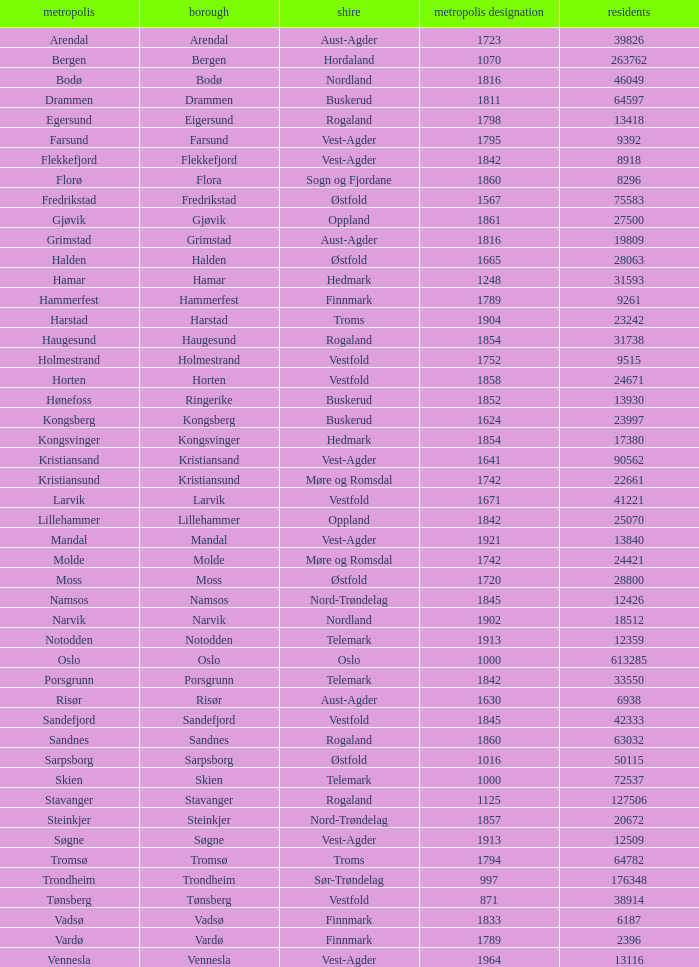Parse the full table. {'header': ['metropolis', 'borough', 'shire', 'metropolis designation', 'residents'], 'rows': [['Arendal', 'Arendal', 'Aust-Agder', '1723', '39826'], ['Bergen', 'Bergen', 'Hordaland', '1070', '263762'], ['Bodø', 'Bodø', 'Nordland', '1816', '46049'], ['Drammen', 'Drammen', 'Buskerud', '1811', '64597'], ['Egersund', 'Eigersund', 'Rogaland', '1798', '13418'], ['Farsund', 'Farsund', 'Vest-Agder', '1795', '9392'], ['Flekkefjord', 'Flekkefjord', 'Vest-Agder', '1842', '8918'], ['Florø', 'Flora', 'Sogn og Fjordane', '1860', '8296'], ['Fredrikstad', 'Fredrikstad', 'Østfold', '1567', '75583'], ['Gjøvik', 'Gjøvik', 'Oppland', '1861', '27500'], ['Grimstad', 'Grimstad', 'Aust-Agder', '1816', '19809'], ['Halden', 'Halden', 'Østfold', '1665', '28063'], ['Hamar', 'Hamar', 'Hedmark', '1248', '31593'], ['Hammerfest', 'Hammerfest', 'Finnmark', '1789', '9261'], ['Harstad', 'Harstad', 'Troms', '1904', '23242'], ['Haugesund', 'Haugesund', 'Rogaland', '1854', '31738'], ['Holmestrand', 'Holmestrand', 'Vestfold', '1752', '9515'], ['Horten', 'Horten', 'Vestfold', '1858', '24671'], ['Hønefoss', 'Ringerike', 'Buskerud', '1852', '13930'], ['Kongsberg', 'Kongsberg', 'Buskerud', '1624', '23997'], ['Kongsvinger', 'Kongsvinger', 'Hedmark', '1854', '17380'], ['Kristiansand', 'Kristiansand', 'Vest-Agder', '1641', '90562'], ['Kristiansund', 'Kristiansund', 'Møre og Romsdal', '1742', '22661'], ['Larvik', 'Larvik', 'Vestfold', '1671', '41221'], ['Lillehammer', 'Lillehammer', 'Oppland', '1842', '25070'], ['Mandal', 'Mandal', 'Vest-Agder', '1921', '13840'], ['Molde', 'Molde', 'Møre og Romsdal', '1742', '24421'], ['Moss', 'Moss', 'Østfold', '1720', '28800'], ['Namsos', 'Namsos', 'Nord-Trøndelag', '1845', '12426'], ['Narvik', 'Narvik', 'Nordland', '1902', '18512'], ['Notodden', 'Notodden', 'Telemark', '1913', '12359'], ['Oslo', 'Oslo', 'Oslo', '1000', '613285'], ['Porsgrunn', 'Porsgrunn', 'Telemark', '1842', '33550'], ['Risør', 'Risør', 'Aust-Agder', '1630', '6938'], ['Sandefjord', 'Sandefjord', 'Vestfold', '1845', '42333'], ['Sandnes', 'Sandnes', 'Rogaland', '1860', '63032'], ['Sarpsborg', 'Sarpsborg', 'Østfold', '1016', '50115'], ['Skien', 'Skien', 'Telemark', '1000', '72537'], ['Stavanger', 'Stavanger', 'Rogaland', '1125', '127506'], ['Steinkjer', 'Steinkjer', 'Nord-Trøndelag', '1857', '20672'], ['Søgne', 'Søgne', 'Vest-Agder', '1913', '12509'], ['Tromsø', 'Tromsø', 'Troms', '1794', '64782'], ['Trondheim', 'Trondheim', 'Sør-Trøndelag', '997', '176348'], ['Tønsberg', 'Tønsberg', 'Vestfold', '871', '38914'], ['Vadsø', 'Vadsø', 'Finnmark', '1833', '6187'], ['Vardø', 'Vardø', 'Finnmark', '1789', '2396'], ['Vennesla', 'Vennesla', 'Vest-Agder', '1964', '13116']]} Which municipality has a population of 24421? Molde. 